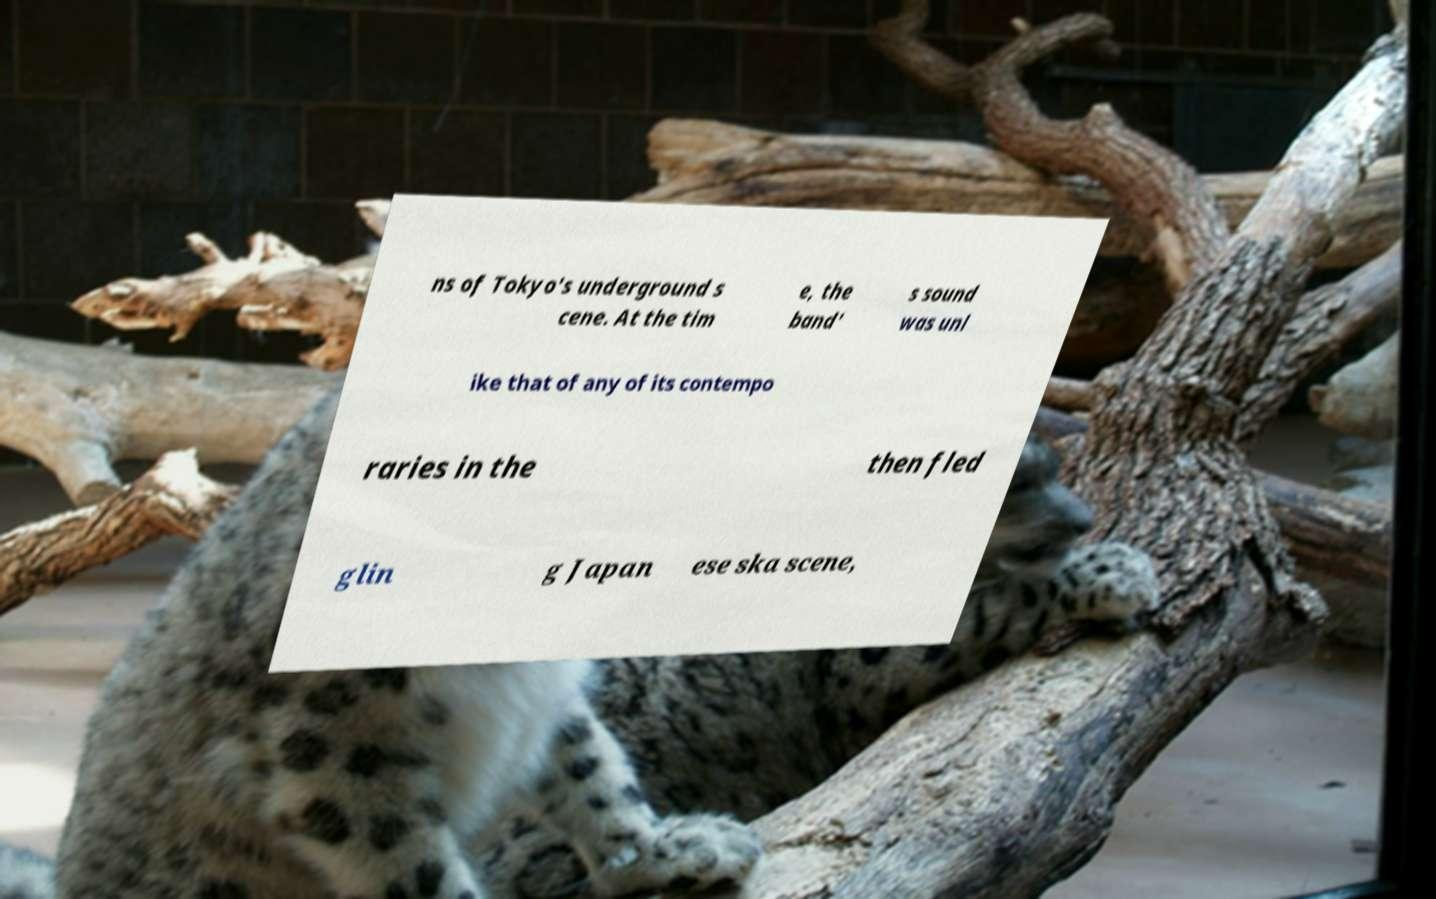Could you assist in decoding the text presented in this image and type it out clearly? ns of Tokyo's underground s cene. At the tim e, the band' s sound was unl ike that of any of its contempo raries in the then fled glin g Japan ese ska scene, 